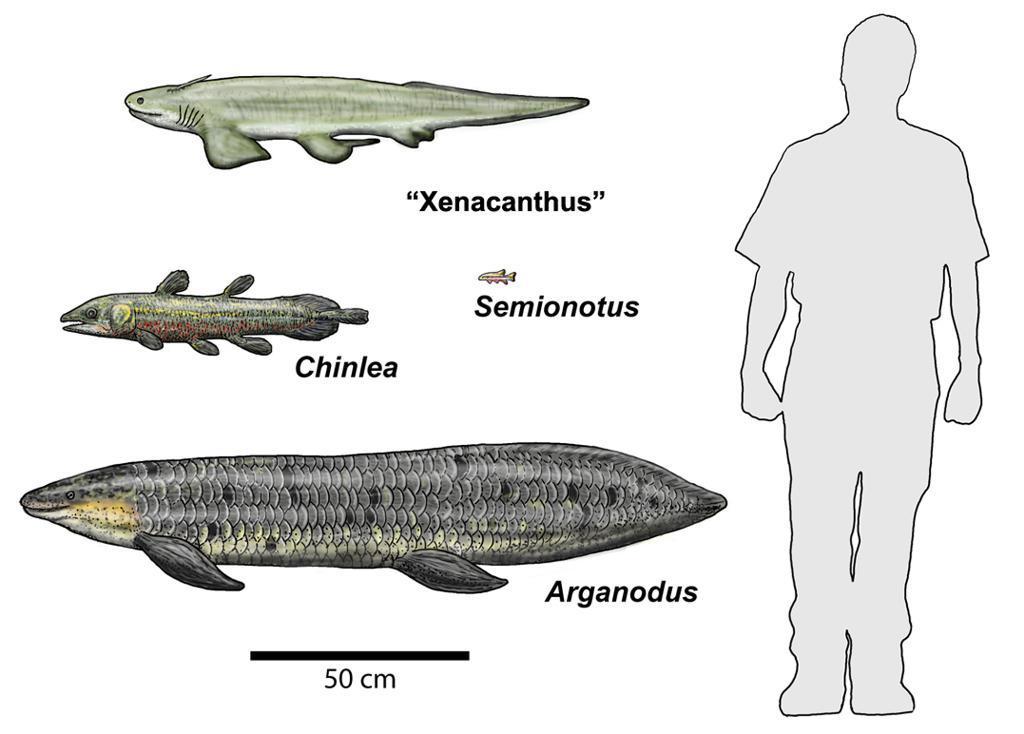Describe this image in one or two sentences. In this picture I can see the fishes. I can see the drawing of a person on the right side. I can see the text. 